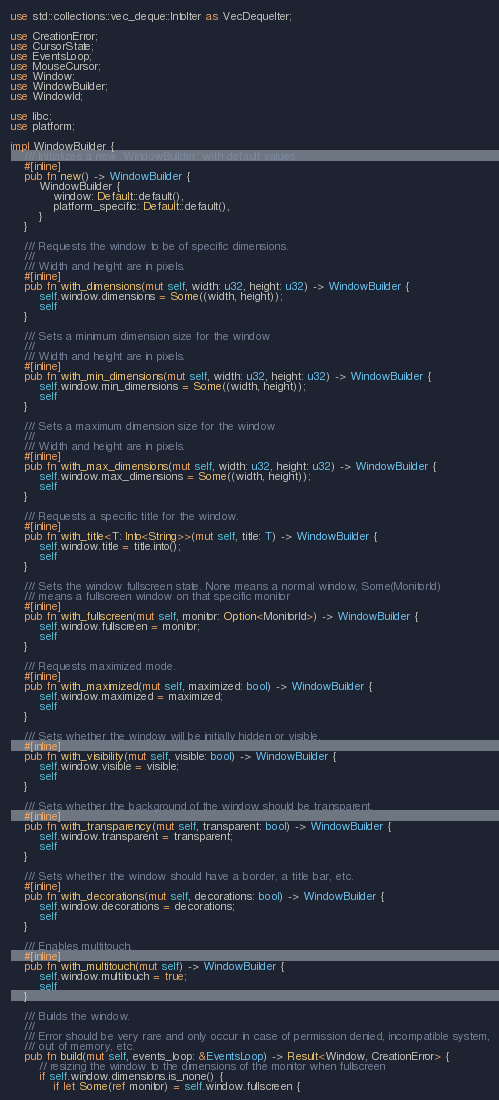Convert code to text. <code><loc_0><loc_0><loc_500><loc_500><_Rust_>use std::collections::vec_deque::IntoIter as VecDequeIter;

use CreationError;
use CursorState;
use EventsLoop;
use MouseCursor;
use Window;
use WindowBuilder;
use WindowId;

use libc;
use platform;

impl WindowBuilder {
    /// Initializes a new `WindowBuilder` with default values.
    #[inline]
    pub fn new() -> WindowBuilder {
        WindowBuilder {
            window: Default::default(),
            platform_specific: Default::default(),
        }
    }

    /// Requests the window to be of specific dimensions.
    ///
    /// Width and height are in pixels.
    #[inline]
    pub fn with_dimensions(mut self, width: u32, height: u32) -> WindowBuilder {
        self.window.dimensions = Some((width, height));
        self
    }

    /// Sets a minimum dimension size for the window
    ///
    /// Width and height are in pixels.
    #[inline]
    pub fn with_min_dimensions(mut self, width: u32, height: u32) -> WindowBuilder {
        self.window.min_dimensions = Some((width, height));
        self
    }

    /// Sets a maximum dimension size for the window
    ///
    /// Width and height are in pixels.
    #[inline]
    pub fn with_max_dimensions(mut self, width: u32, height: u32) -> WindowBuilder {
        self.window.max_dimensions = Some((width, height));
        self
    }

    /// Requests a specific title for the window.
    #[inline]
    pub fn with_title<T: Into<String>>(mut self, title: T) -> WindowBuilder {
        self.window.title = title.into();
        self
    }

    /// Sets the window fullscreen state. None means a normal window, Some(MonitorId)
    /// means a fullscreen window on that specific monitor
    #[inline]
    pub fn with_fullscreen(mut self, monitor: Option<MonitorId>) -> WindowBuilder {
        self.window.fullscreen = monitor;
        self
    }

    /// Requests maximized mode.
    #[inline]
    pub fn with_maximized(mut self, maximized: bool) -> WindowBuilder {
        self.window.maximized = maximized;
        self
    }

    /// Sets whether the window will be initially hidden or visible.
    #[inline]
    pub fn with_visibility(mut self, visible: bool) -> WindowBuilder {
        self.window.visible = visible;
        self
    }

    /// Sets whether the background of the window should be transparent.
    #[inline]
    pub fn with_transparency(mut self, transparent: bool) -> WindowBuilder {
        self.window.transparent = transparent;
        self
    }

    /// Sets whether the window should have a border, a title bar, etc.
    #[inline]
    pub fn with_decorations(mut self, decorations: bool) -> WindowBuilder {
        self.window.decorations = decorations;
        self
    }

    /// Enables multitouch.
    #[inline]
    pub fn with_multitouch(mut self) -> WindowBuilder {
        self.window.multitouch = true;
        self
    }

    /// Builds the window.
    ///
    /// Error should be very rare and only occur in case of permission denied, incompatible system,
    /// out of memory, etc.
    pub fn build(mut self, events_loop: &EventsLoop) -> Result<Window, CreationError> {
        // resizing the window to the dimensions of the monitor when fullscreen
        if self.window.dimensions.is_none() {
            if let Some(ref monitor) = self.window.fullscreen {</code> 